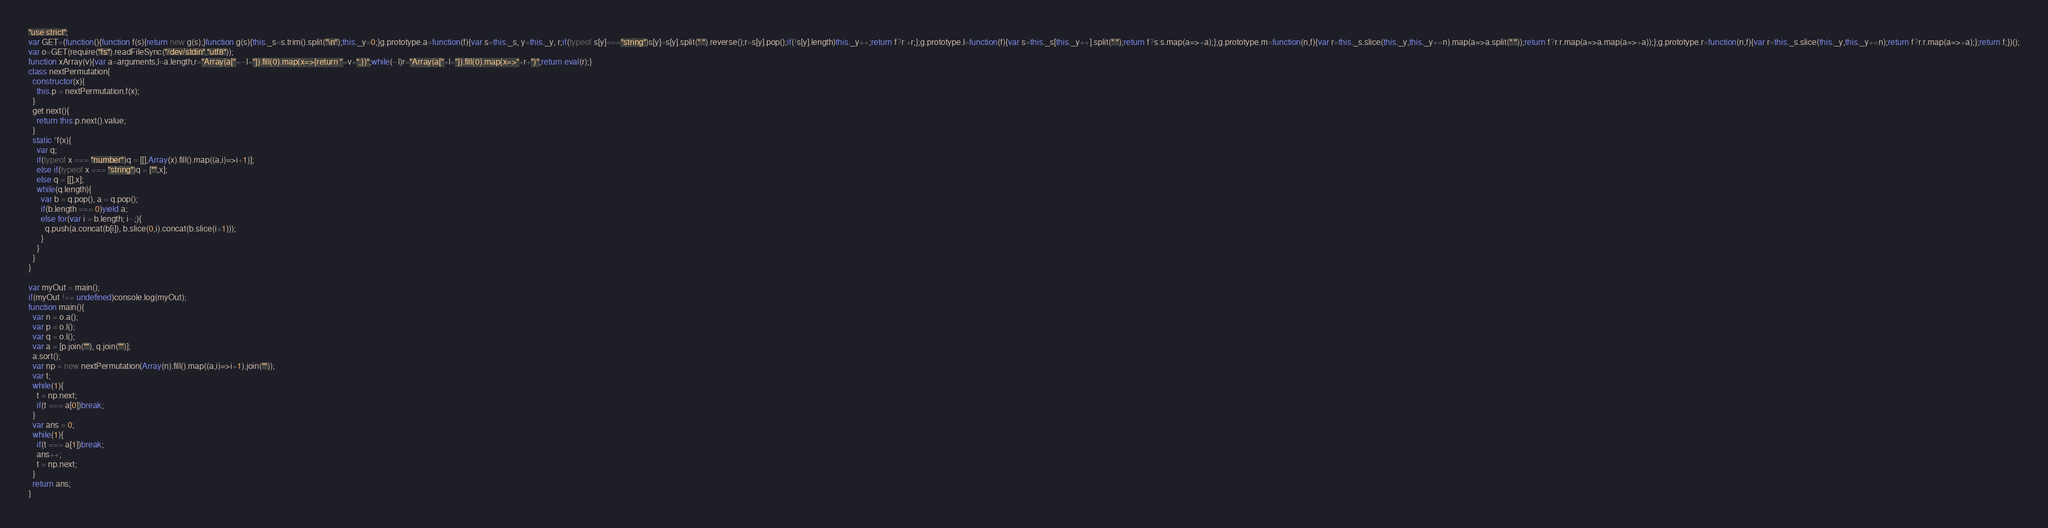<code> <loc_0><loc_0><loc_500><loc_500><_JavaScript_>"use strict";
var GET=(function(){function f(s){return new g(s);}function g(s){this._s=s.trim().split("\n");this._y=0;}g.prototype.a=function(f){var s=this._s, y=this._y, r;if(typeof s[y]==="string")s[y]=s[y].split(" ").reverse();r=s[y].pop();if(!s[y].length)this._y++;return f?r:+r;};g.prototype.l=function(f){var s=this._s[this._y++].split(" ");return f?s:s.map(a=>+a);};g.prototype.m=function(n,f){var r=this._s.slice(this._y,this._y+=n).map(a=>a.split(" "));return f?r:r.map(a=>a.map(a=>+a));};g.prototype.r=function(n,f){var r=this._s.slice(this._y,this._y+=n);return f?r:r.map(a=>+a);};return f;})();
var o=GET(require("fs").readFileSync("/dev/stdin","utf8"));
function xArray(v){var a=arguments,l=a.length,r="Array(a["+--l+"]).fill(0).map(x=>{return "+v+";})";while(--l)r="Array(a["+l+"]).fill(0).map(x=>"+r+")";return eval(r);}
class nextPermutation{
  constructor(x){
    this.p = nextPermutation.f(x);
  }
  get next(){
    return this.p.next().value;
  }
  static *f(x){
    var q;
    if(typeof x === "number")q = [[],Array(x).fill().map((a,i)=>i+1)];
    else if(typeof x === "string")q = ["",x];
    else q = [[],x];
    while(q.length){
      var b = q.pop(), a = q.pop();
      if(b.length === 0)yield a;
      else for(var i = b.length; i--;){
        q.push(a.concat(b[i]), b.slice(0,i).concat(b.slice(i+1)));
      }
    }
  }
}

var myOut = main();
if(myOut !== undefined)console.log(myOut);
function main(){
  var n = o.a();
  var p = o.l();
  var q = o.l();
  var a = [p.join(""), q.join("")];
  a.sort();
  var np = new nextPermutation(Array(n).fill().map((a,i)=>i+1).join(""));
  var t;
  while(1){
    t = np.next;
    if(t === a[0])break;
  }
  var ans = 0;
  while(1){
    if(t === a[1])break;
    ans++;
    t = np.next;
  }
  return ans;
}</code> 